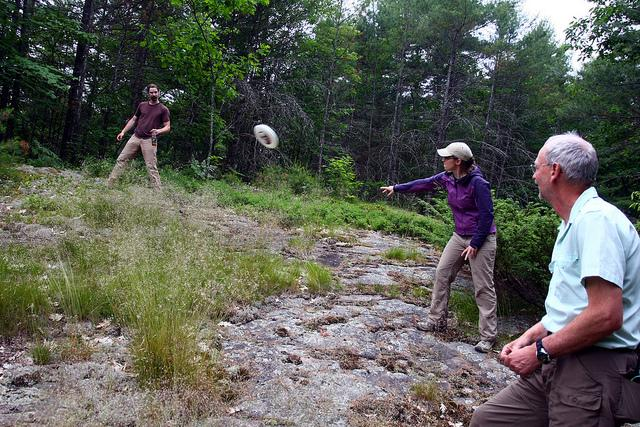Who is standing at a higher level on the rock? brown tshirt 